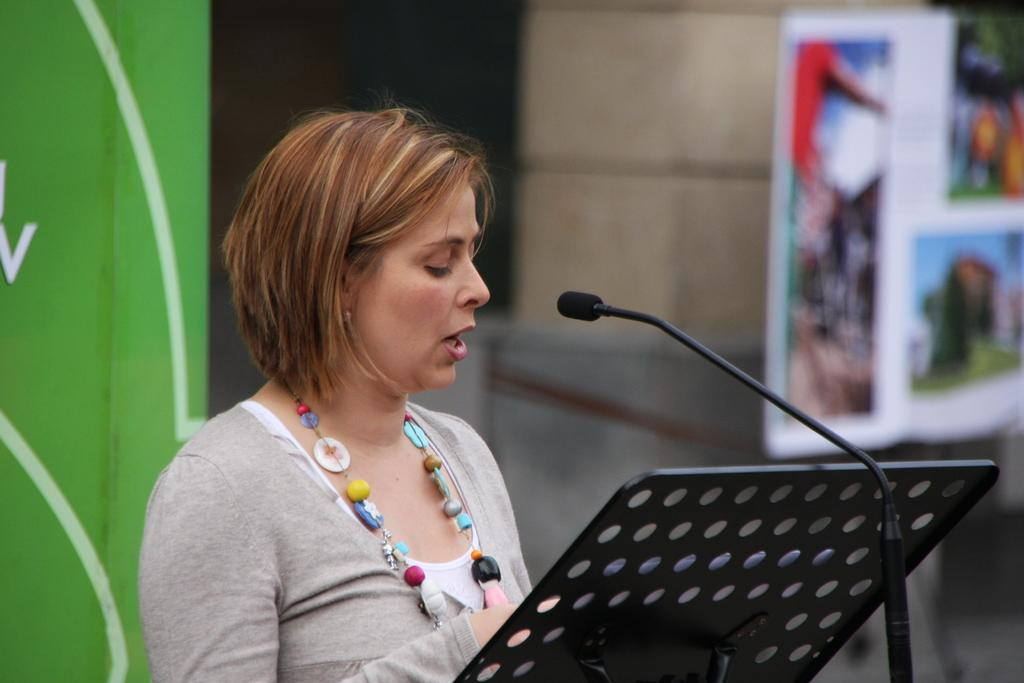Who is the main subject in the image? There is a woman in the image. What is the woman doing in the image? The woman is talking in the image. What object is in front of the woman? There is a microphone in front of the woman. What is the woman standing in front of? There is a stand in front of the woman. What color is the area behind the woman? The area behind the woman is green. How would you describe the background of the image? The background of the image is blurry. What type of yam is being distributed in the image? There is no yam or distribution activity present in the image. How is the woman using the whip in the image? There is no whip present in the image, and the woman is not using any such object. 